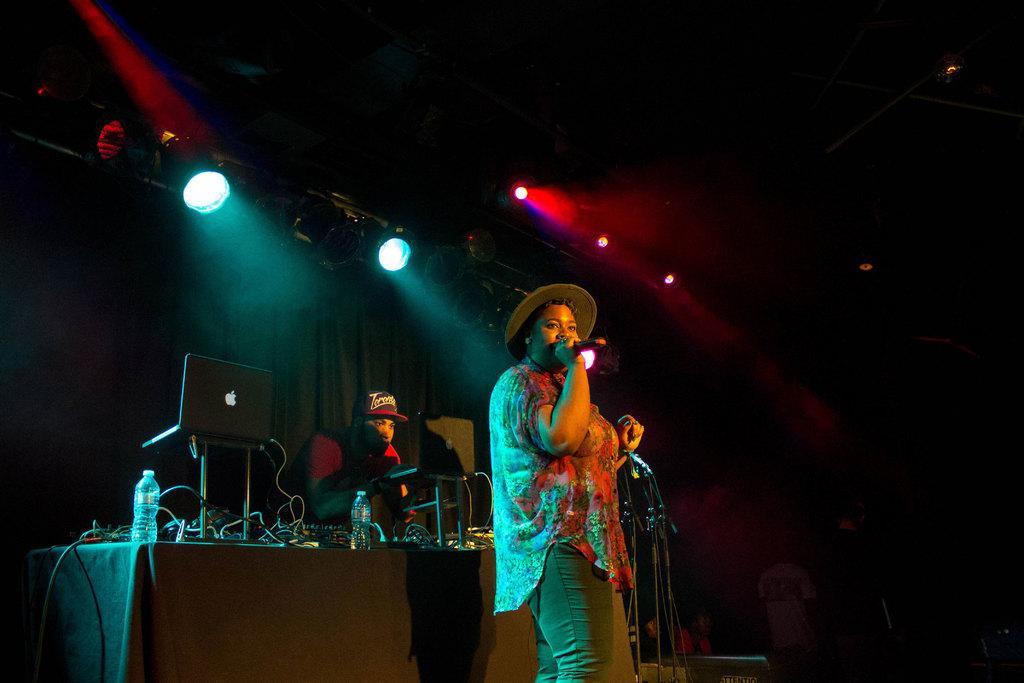Please provide a concise description of this image. This picture describes about group of people, in the middle of the image we can see a woman, she wore a cap and she is singing with the help of microphone, behind to her we can see few laptops, bottles and other things on the table, in the background we can see few lights and metal rods. 